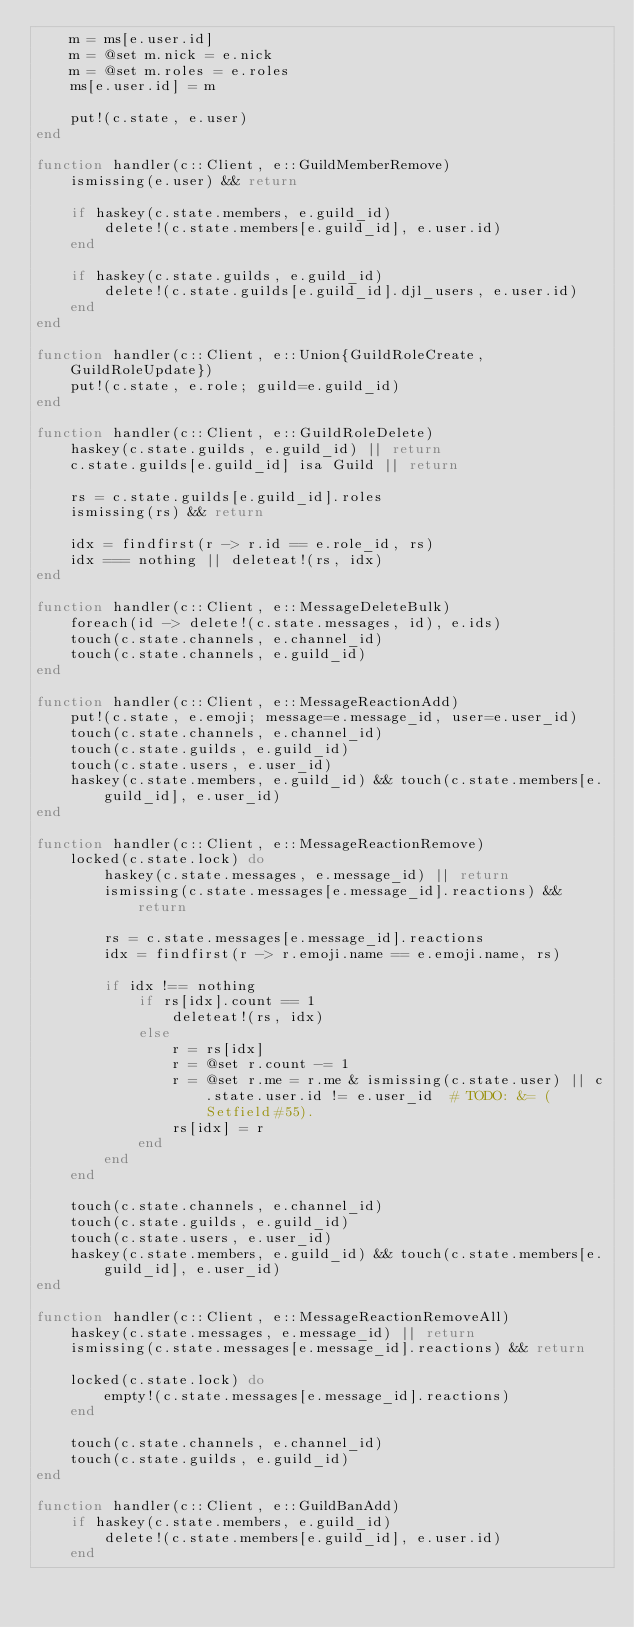<code> <loc_0><loc_0><loc_500><loc_500><_Julia_>    m = ms[e.user.id]
    m = @set m.nick = e.nick
    m = @set m.roles = e.roles
    ms[e.user.id] = m

    put!(c.state, e.user)
end

function handler(c::Client, e::GuildMemberRemove)
    ismissing(e.user) && return
    
    if haskey(c.state.members, e.guild_id)
        delete!(c.state.members[e.guild_id], e.user.id)
    end
    
    if haskey(c.state.guilds, e.guild_id)
        delete!(c.state.guilds[e.guild_id].djl_users, e.user.id)
    end
end

function handler(c::Client, e::Union{GuildRoleCreate, GuildRoleUpdate})
    put!(c.state, e.role; guild=e.guild_id)
end

function handler(c::Client, e::GuildRoleDelete)
    haskey(c.state.guilds, e.guild_id) || return
    c.state.guilds[e.guild_id] isa Guild || return
    
    rs = c.state.guilds[e.guild_id].roles
    ismissing(rs) && return

    idx = findfirst(r -> r.id == e.role_id, rs)
    idx === nothing || deleteat!(rs, idx)
end

function handler(c::Client, e::MessageDeleteBulk)
    foreach(id -> delete!(c.state.messages, id), e.ids)
    touch(c.state.channels, e.channel_id)
    touch(c.state.channels, e.guild_id)
end

function handler(c::Client, e::MessageReactionAdd)
    put!(c.state, e.emoji; message=e.message_id, user=e.user_id)
    touch(c.state.channels, e.channel_id)
    touch(c.state.guilds, e.guild_id)
    touch(c.state.users, e.user_id)
    haskey(c.state.members, e.guild_id) && touch(c.state.members[e.guild_id], e.user_id)
end

function handler(c::Client, e::MessageReactionRemove)
    locked(c.state.lock) do
        haskey(c.state.messages, e.message_id) || return
        ismissing(c.state.messages[e.message_id].reactions) && return

        rs = c.state.messages[e.message_id].reactions
        idx = findfirst(r -> r.emoji.name == e.emoji.name, rs)
        
        if idx !== nothing
            if rs[idx].count == 1
                deleteat!(rs, idx)
            else
                r = rs[idx]
                r = @set r.count -= 1
                r = @set r.me = r.me & ismissing(c.state.user) || c.state.user.id != e.user_id  # TODO: &= (Setfield#55).
                rs[idx] = r
            end
        end
    end

    touch(c.state.channels, e.channel_id)
    touch(c.state.guilds, e.guild_id)
    touch(c.state.users, e.user_id)
    haskey(c.state.members, e.guild_id) && touch(c.state.members[e.guild_id], e.user_id)
end

function handler(c::Client, e::MessageReactionRemoveAll)
    haskey(c.state.messages, e.message_id) || return
    ismissing(c.state.messages[e.message_id].reactions) && return

    locked(c.state.lock) do
        empty!(c.state.messages[e.message_id].reactions)
    end

    touch(c.state.channels, e.channel_id)
    touch(c.state.guilds, e.guild_id)
end

function handler(c::Client, e::GuildBanAdd)
    if haskey(c.state.members, e.guild_id)
        delete!(c.state.members[e.guild_id], e.user.id)
    end
    </code> 